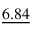Convert formula to latex. <formula><loc_0><loc_0><loc_500><loc_500>\underline { 6 . 8 4 }</formula> 